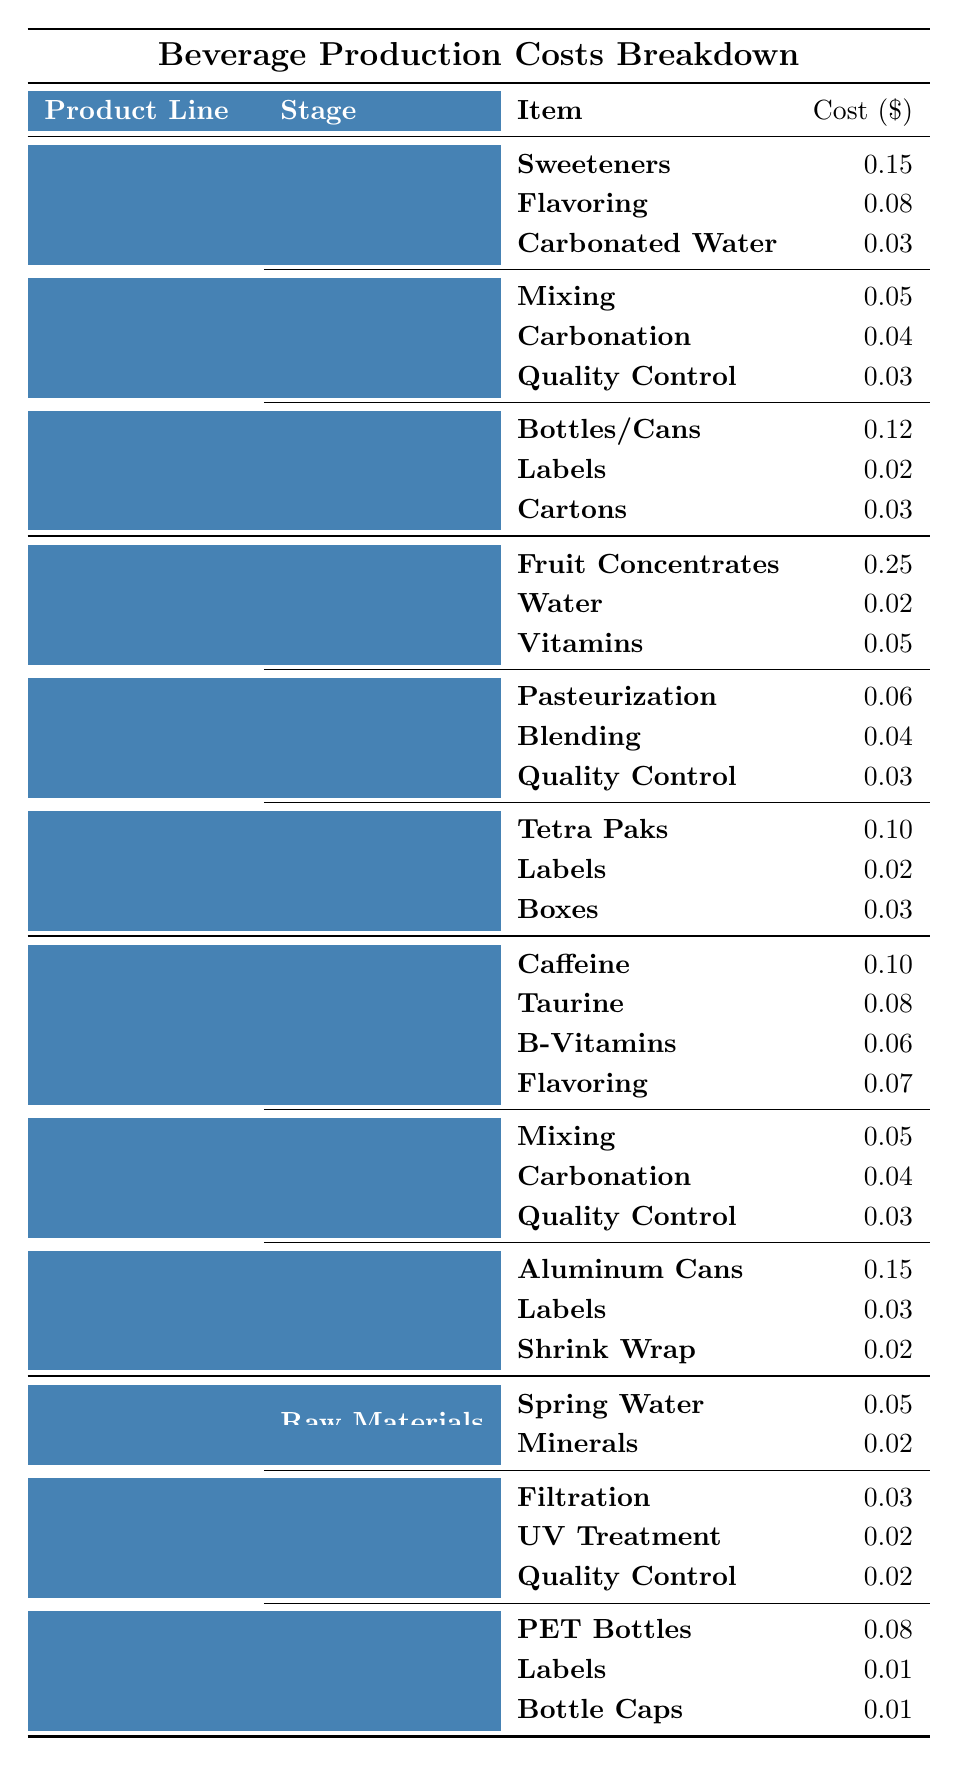What is the cost of Sweeteners in Carbonated Soft Drinks? The table shows that in the Raw Materials stage for Carbonated Soft Drinks, the cost of Sweeteners is listed as 0.15.
Answer: 0.15 What is the total cost of packaging for Fruit Juices? To find the total cost of packaging for Fruit Juices, we sum the costs of Tetra Paks (0.10), Labels (0.02), and Boxes (0.03): 0.10 + 0.02 + 0.03 = 0.15.
Answer: 0.15 Is the cost of Quality Control more in Energy Drinks or Carbonated Soft Drinks? The cost of Quality Control in Energy Drinks is 0.03 and in Carbonated Soft Drinks is also 0.03. Since both values are equal, the answer is no.
Answer: No What is the average cost of Raw Materials across all product lines? Summing the costs of Raw Materials: Carbonated Soft Drinks (0.15 + 0.08 + 0.03 = 0.26), Fruit Juices (0.25 + 0.02 + 0.05 = 0.32), Energy Drinks (0.10 + 0.08 + 0.06 + 0.07 = 0.31), Bottled Water (0.05 + 0.02 = 0.07). The total is 0.26 + 0.32 + 0.31 + 0.07 = 0.96. There are 4 product lines, so the average is 0.96 / 4 = 0.24.
Answer: 0.24 Which product line has the highest total cost in the Processing stage? Calculating the total costs for each product line in Processing, we have: Carbonated Soft Drinks (0.05 + 0.04 + 0.03 = 0.12), Fruit Juices (0.06 + 0.04 + 0.03 = 0.13), Energy Drinks (0.05 + 0.04 + 0.03 = 0.12), and Bottled Water (0.03 + 0.02 + 0.02 = 0.07). The highest total cost is for Fruit Juices at 0.13.
Answer: Fruit Juices What is the difference in total packaging costs between Energy Drinks and Bottled Water? First, calculate the total packaging costs: Energy Drinks (0.15 + 0.03 + 0.02 = 0.20), Bottled Water (0.08 + 0.01 + 0.01 = 0.10). The difference is 0.20 - 0.10 = 0.10.
Answer: 0.10 Are the costs of the ingredients for Bottled Water higher, equal to, or lower than those for Carbonated Soft Drinks in the Raw Materials stage? For Bottled Water, the Raw Materials cost is 0.05 + 0.02 = 0.07. For Carbonated Soft Drinks, it is 0.15 + 0.08 + 0.03 = 0.26. Since 0.07 is lower than 0.26, the answer is lower.
Answer: Lower Which item from the Raw Materials stage in Energy Drinks costs the most? The costs of Raw Materials for Energy Drinks are Caffeine (0.10), Taurine (0.08), B-Vitamins (0.06), and Flavoring (0.07). Comparing these values, Caffeine at 0.10 is the highest.
Answer: Caffeine What is the total cost of all stages for the Fruit Juices product line? We need to calculate the total for each stage: Raw Materials (0.25 + 0.02 + 0.05 = 0.32), Processing (0.06 + 0.04 + 0.03 = 0.13), Packaging (0.10 + 0.02 + 0.03 = 0.15). Adding these totals gives us: 0.32 + 0.13 + 0.15 = 0.60.
Answer: 0.60 Which product line's total costs in the Processing stage is equal to the total cost of Raw Materials in that same product line? For Carbonated Soft Drinks, the totals are Raw Materials 0.26 and Processing 0.12; for Fruit Juices, Raw Materials 0.32, Processing 0.13; for Energy Drinks, Raw Materials 0.31 and Processing 0.12; for Bottled Water, Raw Materials 0.07 and Processing 0.07. Only Bottled Water has equal totals of 0.07 at both stages.
Answer: Bottled Water 